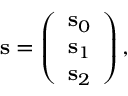<formula> <loc_0><loc_0><loc_500><loc_500>\begin{array} { r } { \mathbf s = \left ( \begin{array} { c } { { \mathbf s } _ { 0 } } \\ { { \mathbf s } _ { 1 } } \\ { { \mathbf s } _ { 2 } } \end{array} \right ) , } \end{array}</formula> 